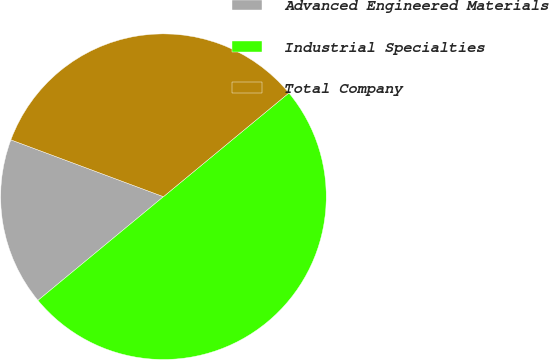Convert chart. <chart><loc_0><loc_0><loc_500><loc_500><pie_chart><fcel>Advanced Engineered Materials<fcel>Industrial Specialties<fcel>Total Company<nl><fcel>16.67%<fcel>50.0%<fcel>33.33%<nl></chart> 